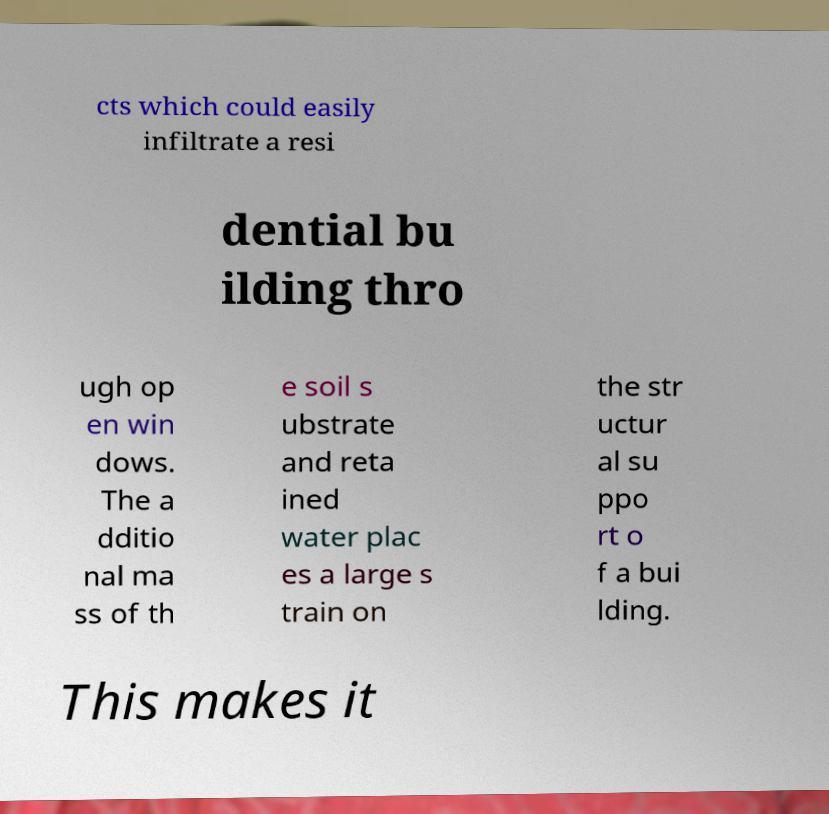Please read and relay the text visible in this image. What does it say? cts which could easily infiltrate a resi dential bu ilding thro ugh op en win dows. The a dditio nal ma ss of th e soil s ubstrate and reta ined water plac es a large s train on the str uctur al su ppo rt o f a bui lding. This makes it 